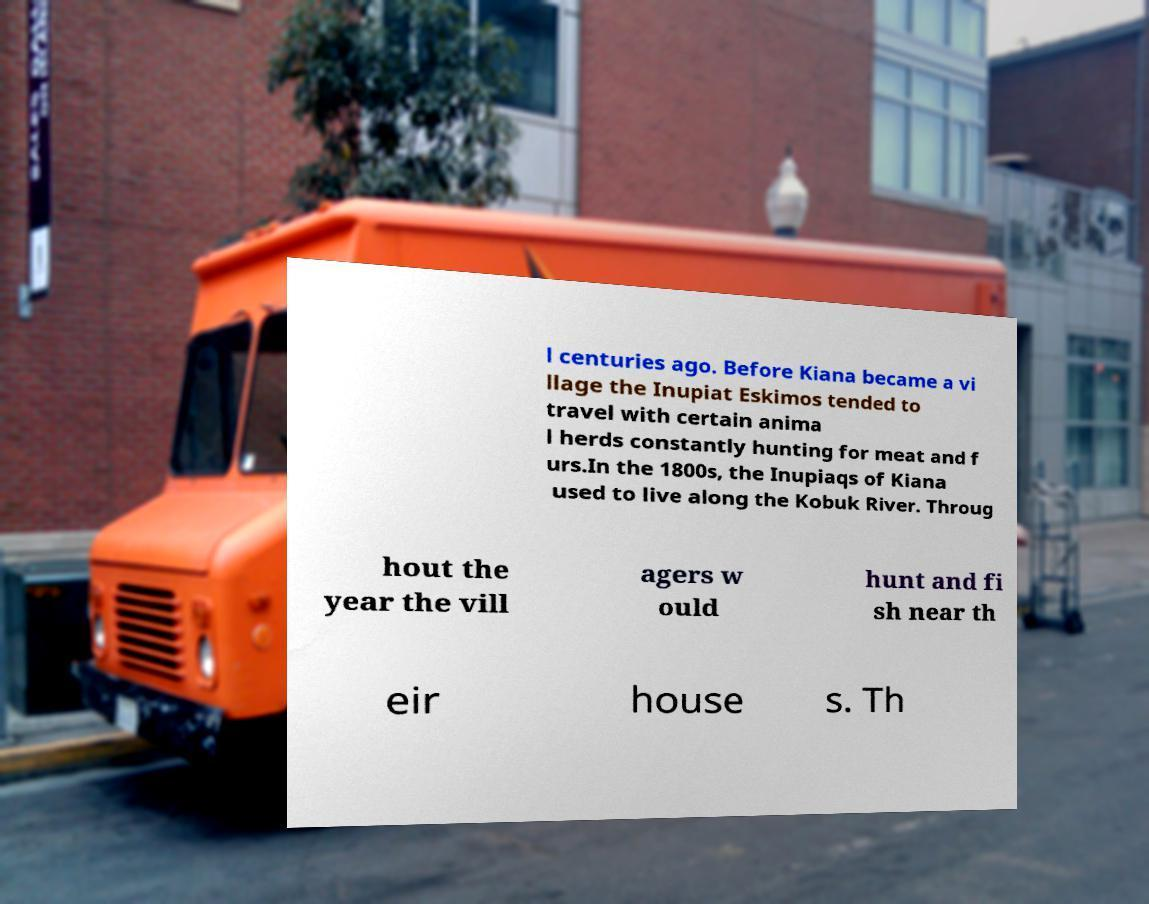Please read and relay the text visible in this image. What does it say? l centuries ago. Before Kiana became a vi llage the Inupiat Eskimos tended to travel with certain anima l herds constantly hunting for meat and f urs.In the 1800s, the Inupiaqs of Kiana used to live along the Kobuk River. Throug hout the year the vill agers w ould hunt and fi sh near th eir house s. Th 